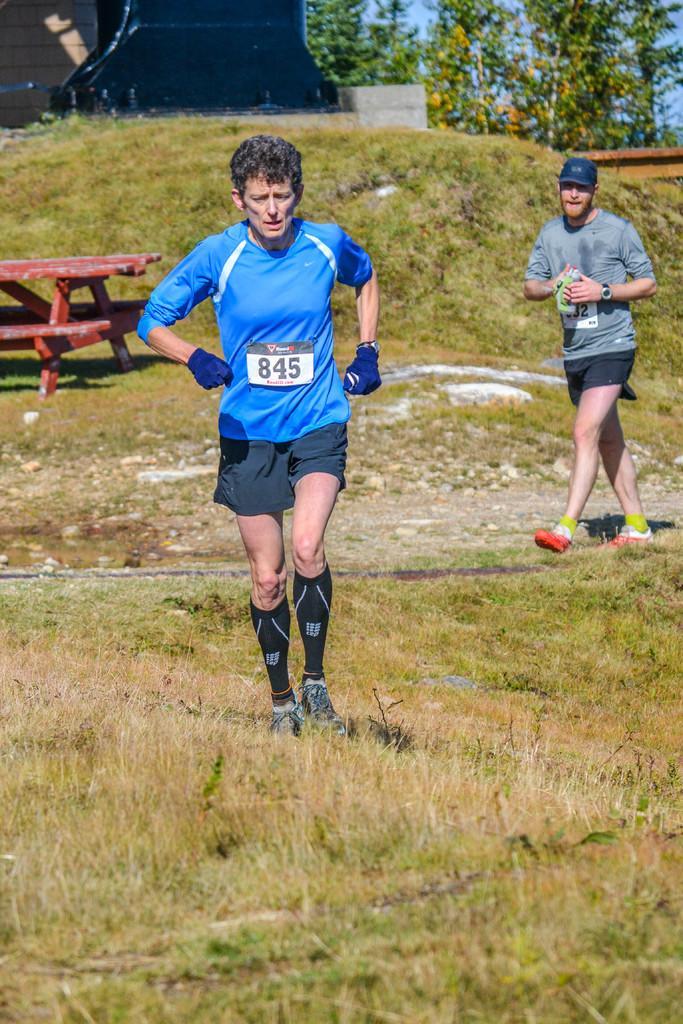Describe this image in one or two sentences. In the middle of this image, there is a person in a blue color t-shirt, running on the ground, on which there is grass. In the background, there is another person in a gray color t-shirt walking, there are two benches and a table arranged, there are trees, blue sky and other objects. 